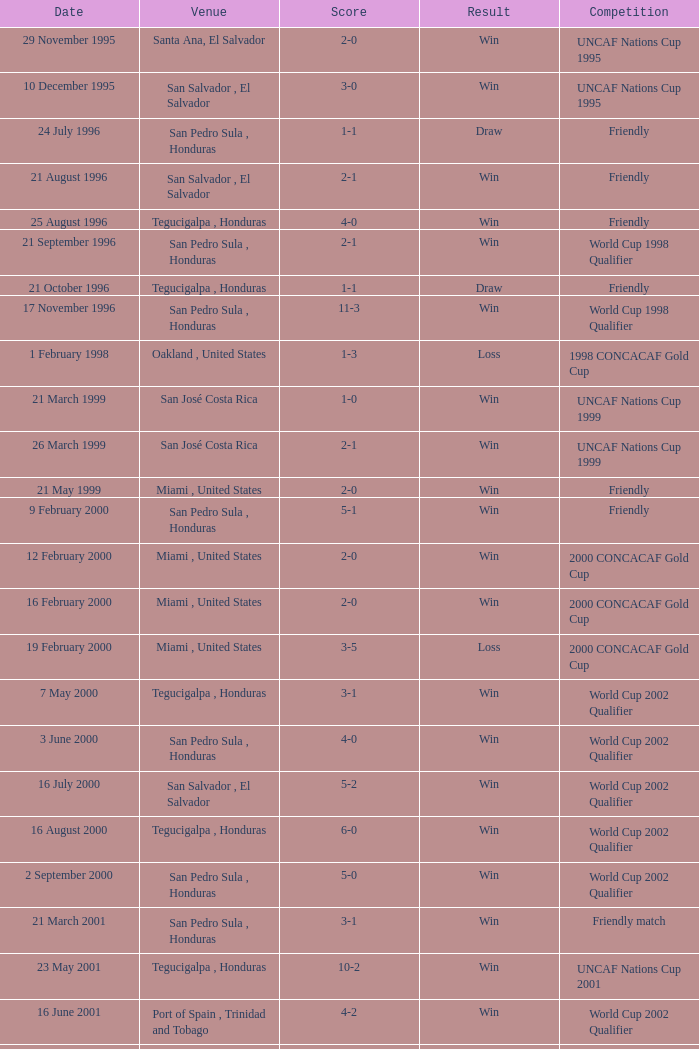Would you mind parsing the complete table? {'header': ['Date', 'Venue', 'Score', 'Result', 'Competition'], 'rows': [['29 November 1995', 'Santa Ana, El Salvador', '2-0', 'Win', 'UNCAF Nations Cup 1995'], ['10 December 1995', 'San Salvador , El Salvador', '3-0', 'Win', 'UNCAF Nations Cup 1995'], ['24 July 1996', 'San Pedro Sula , Honduras', '1-1', 'Draw', 'Friendly'], ['21 August 1996', 'San Salvador , El Salvador', '2-1', 'Win', 'Friendly'], ['25 August 1996', 'Tegucigalpa , Honduras', '4-0', 'Win', 'Friendly'], ['21 September 1996', 'San Pedro Sula , Honduras', '2-1', 'Win', 'World Cup 1998 Qualifier'], ['21 October 1996', 'Tegucigalpa , Honduras', '1-1', 'Draw', 'Friendly'], ['17 November 1996', 'San Pedro Sula , Honduras', '11-3', 'Win', 'World Cup 1998 Qualifier'], ['1 February 1998', 'Oakland , United States', '1-3', 'Loss', '1998 CONCACAF Gold Cup'], ['21 March 1999', 'San José Costa Rica', '1-0', 'Win', 'UNCAF Nations Cup 1999'], ['26 March 1999', 'San José Costa Rica', '2-1', 'Win', 'UNCAF Nations Cup 1999'], ['21 May 1999', 'Miami , United States', '2-0', 'Win', 'Friendly'], ['9 February 2000', 'San Pedro Sula , Honduras', '5-1', 'Win', 'Friendly'], ['12 February 2000', 'Miami , United States', '2-0', 'Win', '2000 CONCACAF Gold Cup'], ['16 February 2000', 'Miami , United States', '2-0', 'Win', '2000 CONCACAF Gold Cup'], ['19 February 2000', 'Miami , United States', '3-5', 'Loss', '2000 CONCACAF Gold Cup'], ['7 May 2000', 'Tegucigalpa , Honduras', '3-1', 'Win', 'World Cup 2002 Qualifier'], ['3 June 2000', 'San Pedro Sula , Honduras', '4-0', 'Win', 'World Cup 2002 Qualifier'], ['16 July 2000', 'San Salvador , El Salvador', '5-2', 'Win', 'World Cup 2002 Qualifier'], ['16 August 2000', 'Tegucigalpa , Honduras', '6-0', 'Win', 'World Cup 2002 Qualifier'], ['2 September 2000', 'San Pedro Sula , Honduras', '5-0', 'Win', 'World Cup 2002 Qualifier'], ['21 March 2001', 'San Pedro Sula , Honduras', '3-1', 'Win', 'Friendly match'], ['23 May 2001', 'Tegucigalpa , Honduras', '10-2', 'Win', 'UNCAF Nations Cup 2001'], ['16 June 2001', 'Port of Spain , Trinidad and Tobago', '4-2', 'Win', 'World Cup 2002 Qualifier'], ['20 June 2001', 'San Pedro Sula , Honduras', '3-1', 'Win', 'World Cup 2002 Qualifier'], ['1 September 2001', 'Washington, D.C. , United States', '2-1', 'Win', 'World Cup 2002 Qualifier'], ['2 May 2002', 'Kobe , Japan', '3-3', 'Draw', 'Carlsberg Cup'], ['28 April 2004', 'Fort Lauderdale , United States', '1-1', 'Draw', 'Friendly'], ['19 June 2004', 'San Pedro Sula , Honduras', '4-0', 'Win', 'World Cup 2006 Qualification'], ['19 April 2007', 'La Ceiba , Honduras', '1-3', 'Loss', 'Friendly'], ['25 May 2007', 'Mérida , Venezuela', '1-2', 'Loss', 'Friendly'], ['13 June 2007', 'Houston , United States', '5-0', 'Win', '2007 CONCACAF Gold Cup'], ['17 June 2007', 'Houston , United States', '1-2', 'Loss', '2007 CONCACAF Gold Cup'], ['18 January 2009', 'Miami , United States', '2-0', 'Win', 'Friendly'], ['26 January 2009', 'Tegucigalpa , Honduras', '2-0', 'Win', 'UNCAF Nations Cup 2009'], ['28 March 2009', 'Port of Spain , Trinidad and Tobago', '1-1', 'Draw', 'World Cup 2010 Qualification'], ['1 April 2009', 'San Pedro Sula , Honduras', '3-1', 'Win', 'World Cup 2010 Qualification'], ['10 June 2009', 'San Pedro Sula , Honduras', '1-0', 'Win', 'World Cup 2010 Qualification'], ['12 August 2009', 'San Pedro Sula , Honduras', '4-0', 'Win', 'World Cup 2010 Qualification'], ['5 September 2009', 'San Pedro Sula , Honduras', '4-1', 'Win', 'World Cup 2010 Qualification'], ['14 October 2009', 'San Salvador , El Salvador', '1-0', 'Win', 'World Cup 2010 Qualification'], ['23 January 2010', 'Carson , United States', '3-1', 'Win', 'Friendly']]} Name the score for 7 may 2000 3-1. 